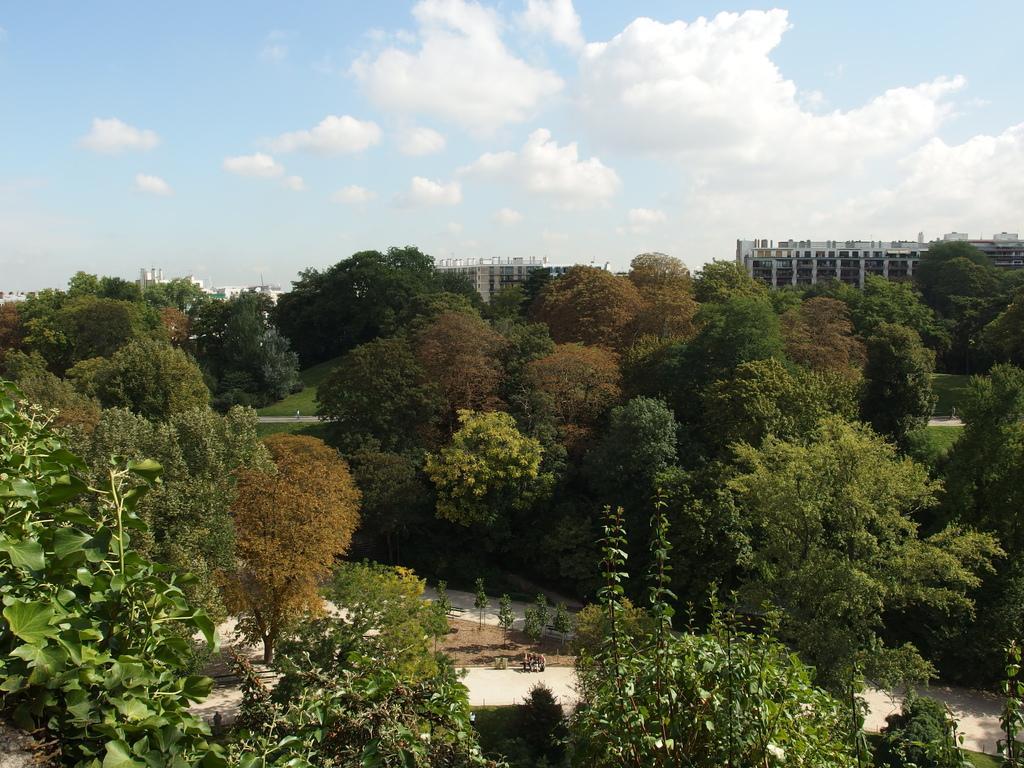Please provide a concise description of this image. In this image, we can see so many trees, plants, footpaths. Background there are so many buildings. Top of the image, there is a cloudy sky. 